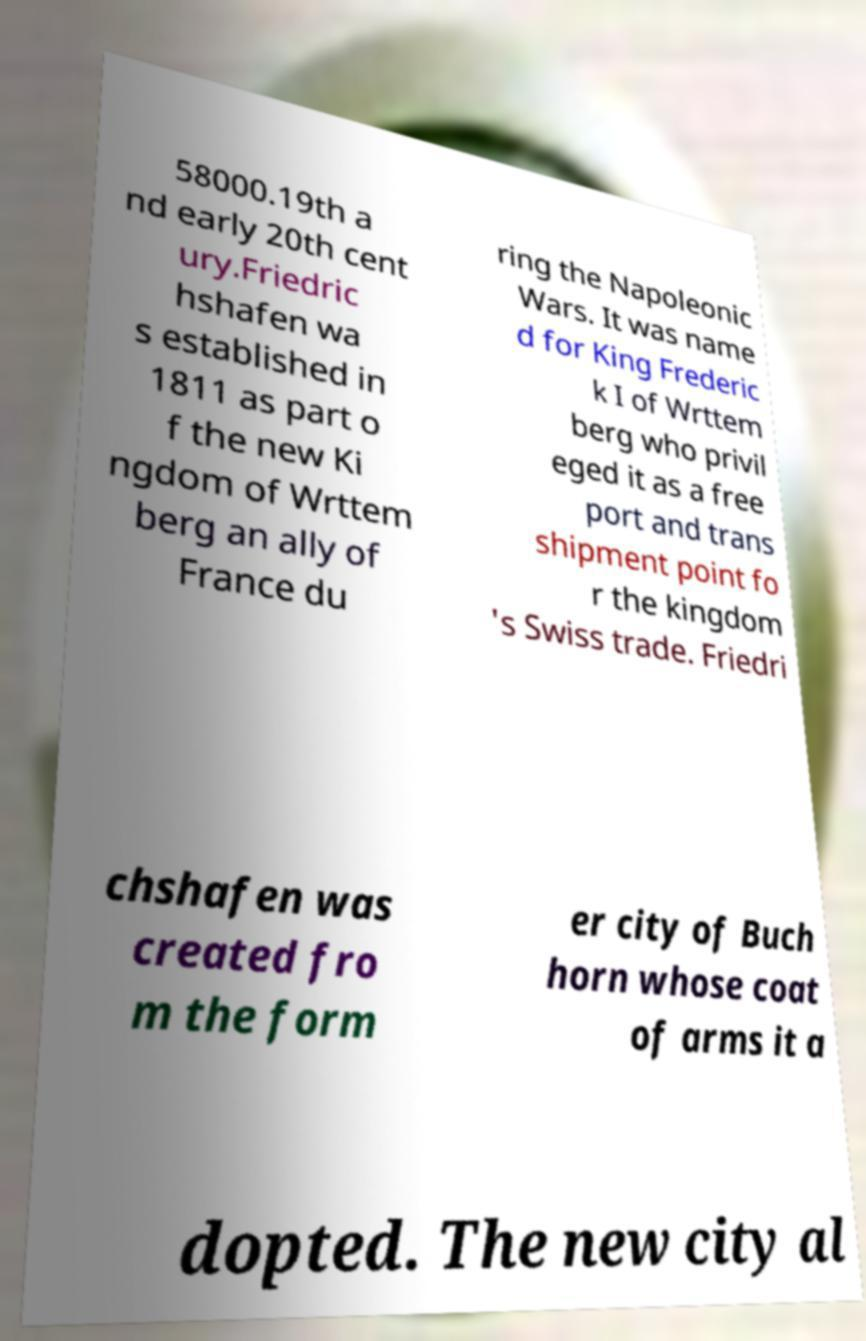Can you read and provide the text displayed in the image?This photo seems to have some interesting text. Can you extract and type it out for me? 58000.19th a nd early 20th cent ury.Friedric hshafen wa s established in 1811 as part o f the new Ki ngdom of Wrttem berg an ally of France du ring the Napoleonic Wars. It was name d for King Frederic k I of Wrttem berg who privil eged it as a free port and trans shipment point fo r the kingdom 's Swiss trade. Friedri chshafen was created fro m the form er city of Buch horn whose coat of arms it a dopted. The new city al 